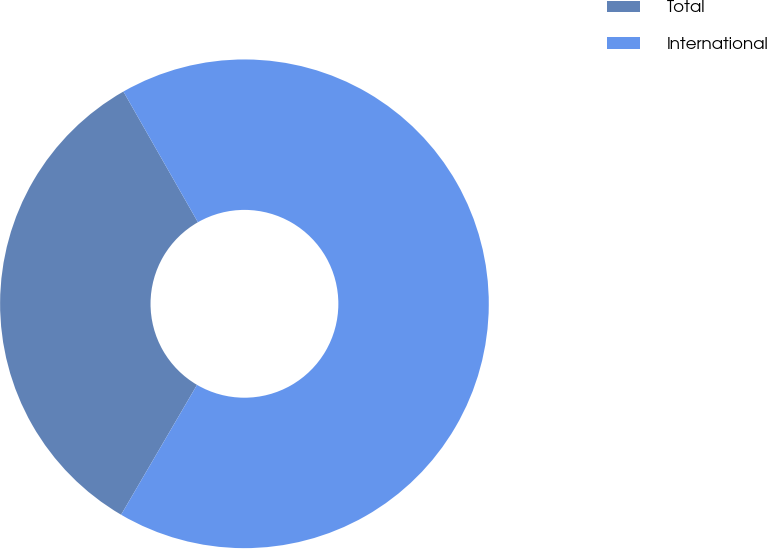Convert chart to OTSL. <chart><loc_0><loc_0><loc_500><loc_500><pie_chart><fcel>Total<fcel>International<nl><fcel>33.33%<fcel>66.67%<nl></chart> 